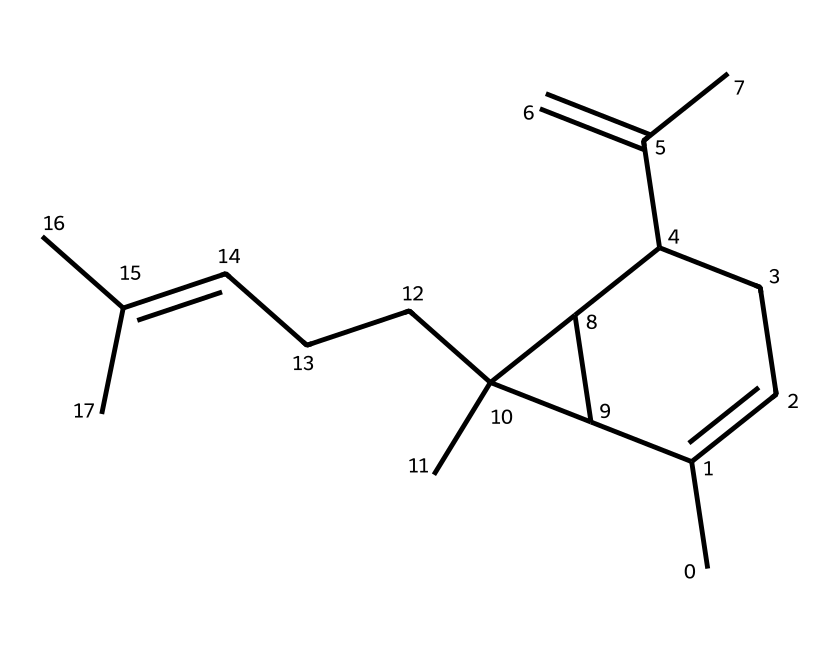How many carbon atoms are in β-caryophyllene? By analyzing the SMILES representation, you can count the 'C' symbols, which denote carbon atoms. There are 15 carbon atoms in total in the structure of β-caryophyllene.
Answer: 15 What is the molecular formula of β-caryophyllene? From the chemical structure, we can derive the molecular formula by counting the carbon and hydrogen atoms. With 15 carbons (C) and 24 hydrogens (H), the molecular formula is C15H24.
Answer: C15H24 Does β-caryophyllene contain any double bonds? By examining the structural representation, we identify the presence of double bonds between certain carbon atoms, indicated by a lack of hydrogen atoms connected to those carbons. β-caryophyllene has two double bonds in its structure.
Answer: yes What kind of compound is β-caryophyllene classified as? β-caryophyllene contains a specific arrangement of carbon and hydrogen atoms arranged in a cyclic structure with a specific branching pattern, which categorizes it as a sesquiterpene.
Answer: sesquiterpene What functional group is prominent in β-caryophyllene? Analyzing the structure reveals that β-caryophyllene features cyclic structures without any additional functional groups present, primarily consisting of hydrocarbons. Therefore, there are no specific functional groups like alcohols or ketones.
Answer: none How many rings are present in β-caryophyllene? Upon examining the structure, we can identify two distinct rings in the representation. Each part of the molecule contributing to the cyclical nature defines these rings.
Answer: 2 